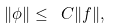<formula> <loc_0><loc_0><loc_500><loc_500>\| \phi \| \leq \ C \| f \| ,</formula> 